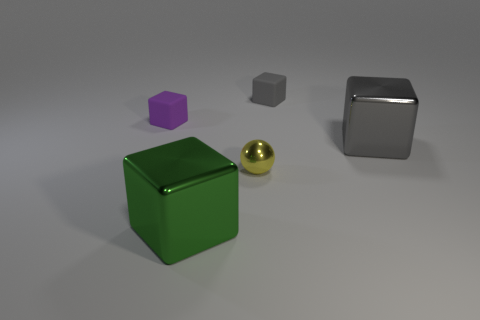What shape is the small yellow object that is the same material as the big green block?
Give a very brief answer. Sphere. Is there anything else that is the same shape as the yellow metallic object?
Your answer should be compact. No. There is a block that is both behind the big gray metallic thing and right of the yellow object; what color is it?
Keep it short and to the point. Gray. What number of cylinders are either tiny gray rubber things or brown rubber objects?
Give a very brief answer. 0. What number of purple rubber things have the same size as the green thing?
Offer a terse response. 0. There is a tiny purple thing behind the green cube; what number of small purple things are to the right of it?
Your response must be concise. 0. There is a object that is on the left side of the yellow shiny object and in front of the large gray thing; what size is it?
Provide a succinct answer. Large. Are there more shiny blocks than metallic things?
Make the answer very short. No. Are there any matte things of the same color as the ball?
Give a very brief answer. No. Do the matte block right of the yellow sphere and the gray metal thing have the same size?
Provide a short and direct response. No. 